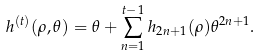<formula> <loc_0><loc_0><loc_500><loc_500>h ^ { ( t ) } ( \rho , \theta ) = \theta + \sum _ { n = 1 } ^ { t - 1 } h _ { 2 n + 1 } ( \rho ) \theta ^ { 2 n + 1 } .</formula> 